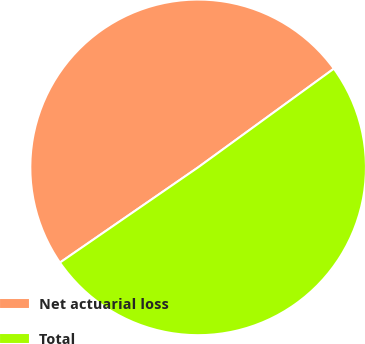<chart> <loc_0><loc_0><loc_500><loc_500><pie_chart><fcel>Net actuarial loss<fcel>Total<nl><fcel>49.6%<fcel>50.4%<nl></chart> 